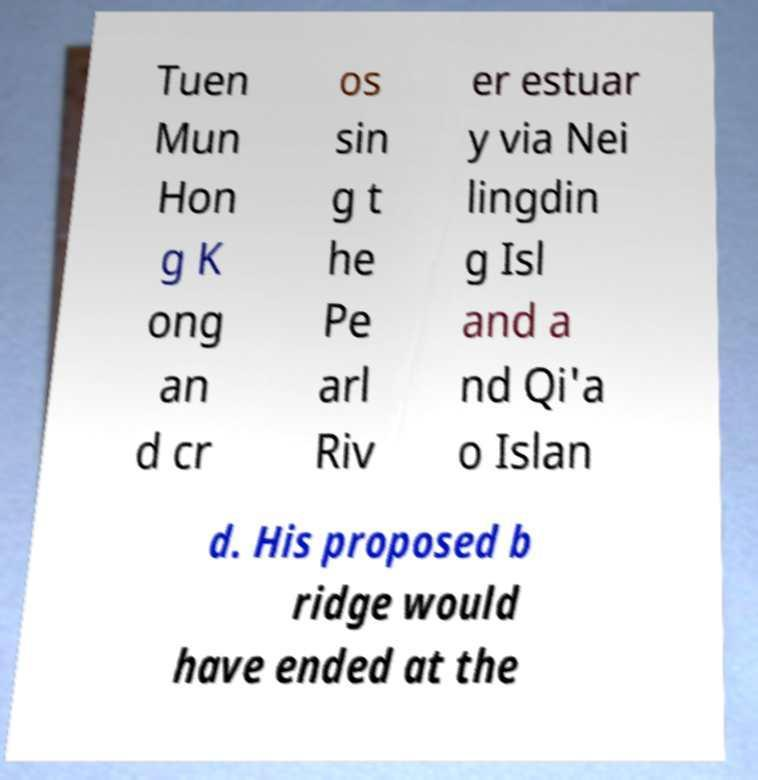For documentation purposes, I need the text within this image transcribed. Could you provide that? Tuen Mun Hon g K ong an d cr os sin g t he Pe arl Riv er estuar y via Nei lingdin g Isl and a nd Qi'a o Islan d. His proposed b ridge would have ended at the 